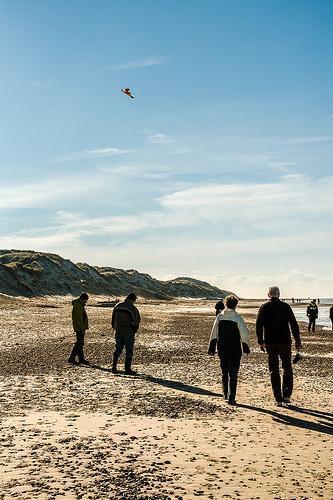How many people are wearing the color white?
Give a very brief answer. 1. 